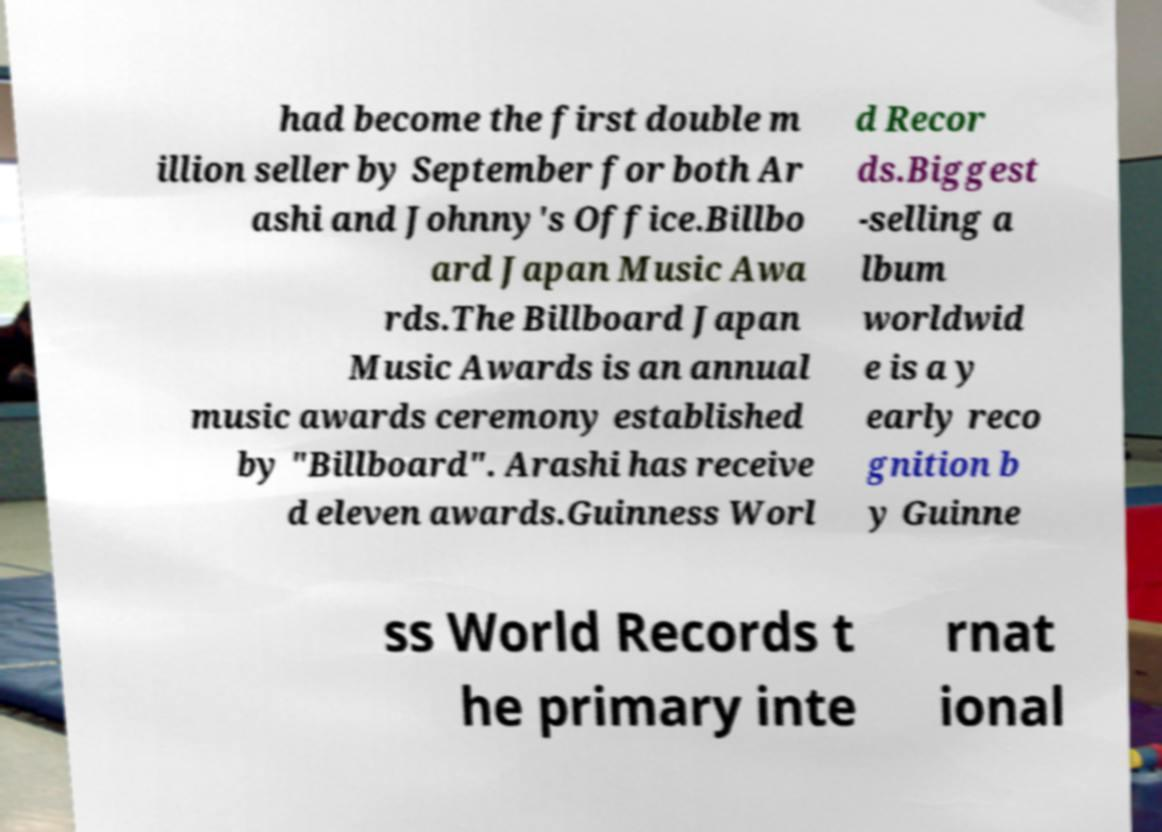What messages or text are displayed in this image? I need them in a readable, typed format. had become the first double m illion seller by September for both Ar ashi and Johnny's Office.Billbo ard Japan Music Awa rds.The Billboard Japan Music Awards is an annual music awards ceremony established by "Billboard". Arashi has receive d eleven awards.Guinness Worl d Recor ds.Biggest -selling a lbum worldwid e is a y early reco gnition b y Guinne ss World Records t he primary inte rnat ional 